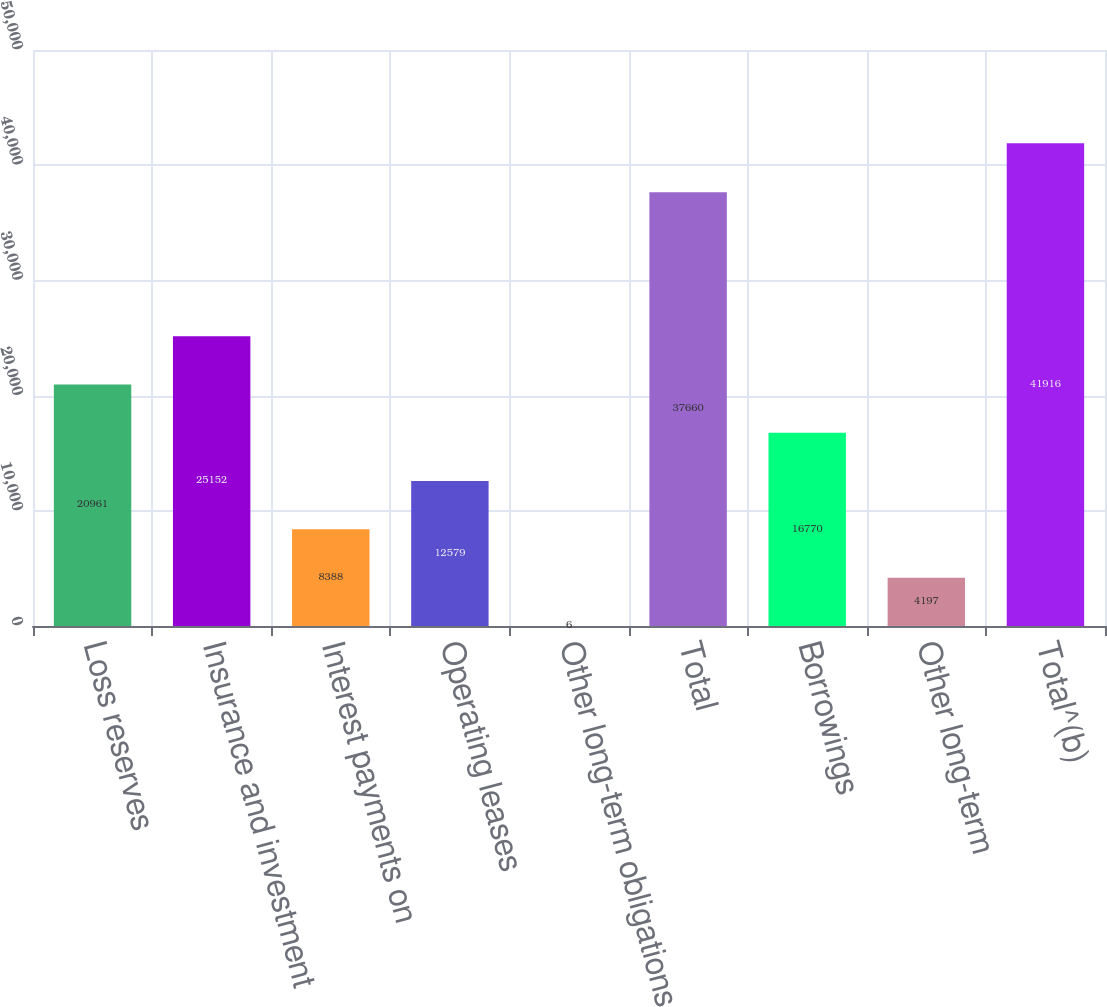Convert chart. <chart><loc_0><loc_0><loc_500><loc_500><bar_chart><fcel>Loss reserves<fcel>Insurance and investment<fcel>Interest payments on<fcel>Operating leases<fcel>Other long-term obligations<fcel>Total<fcel>Borrowings<fcel>Other long-term<fcel>Total^(b)<nl><fcel>20961<fcel>25152<fcel>8388<fcel>12579<fcel>6<fcel>37660<fcel>16770<fcel>4197<fcel>41916<nl></chart> 